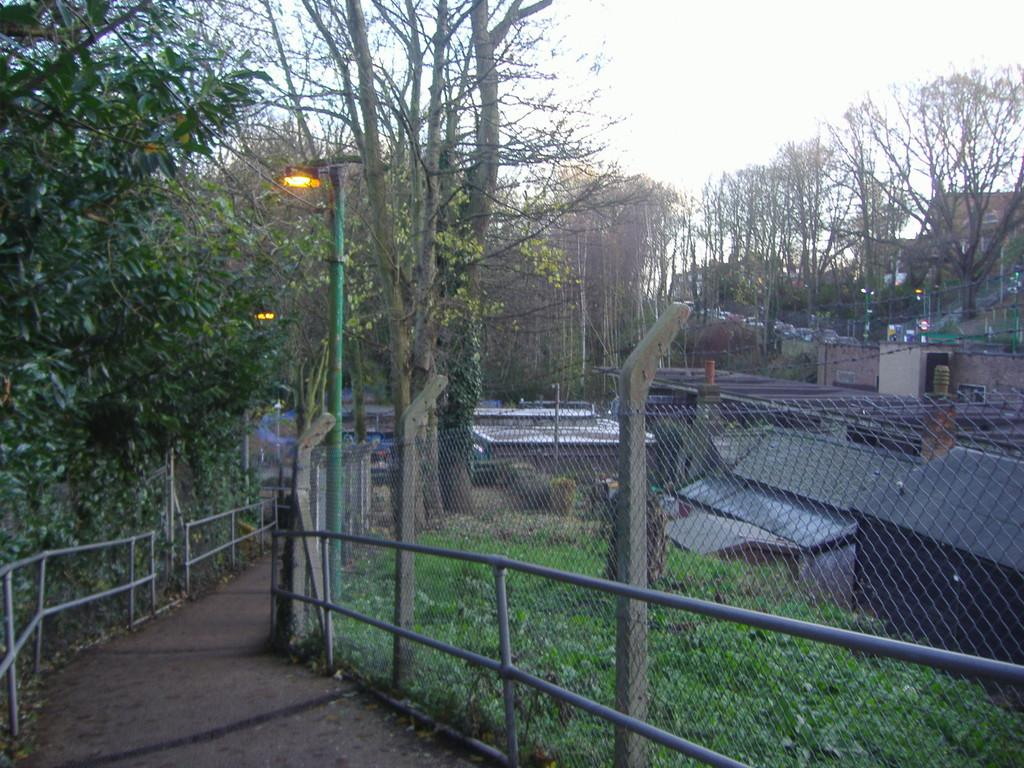What is located at the bottom of the image? There is a walkway at the bottom of the image. What can be seen in the image besides the walkway? There is a fence, sheds, trees, poles, lights, and the sky visible in the image. Where are the sheds located in the image? The sheds are on the right side of the image. What is visible in the background of the image? Trees, poles, lights, and the sky are visible in the background of the image. What type of hospital can be seen in the image? There is no hospital present in the image. Is there a baseball game happening in the image? There is no baseball game or any reference to baseball in the image. 